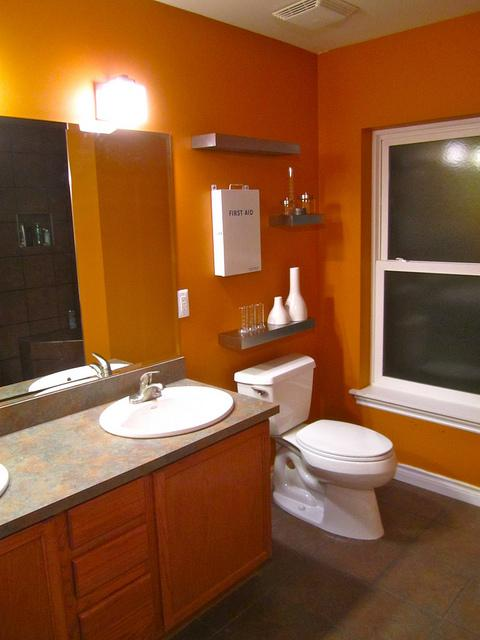What is the toilet near? Please explain your reasoning. window. The toilet's near a window. 